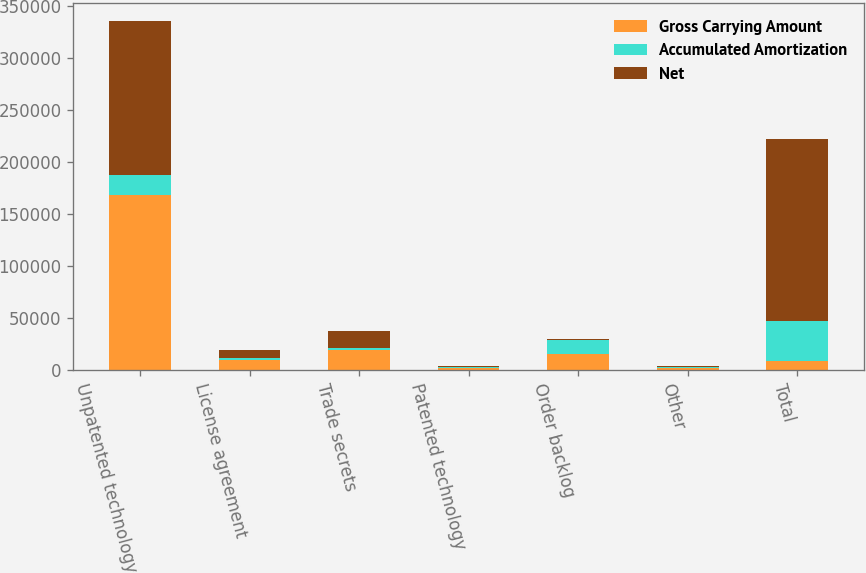Convert chart. <chart><loc_0><loc_0><loc_500><loc_500><stacked_bar_chart><ecel><fcel>Unpatented technology<fcel>License agreement<fcel>Trade secrets<fcel>Patented technology<fcel>Order backlog<fcel>Other<fcel>Total<nl><fcel>Gross Carrying Amount<fcel>168003<fcel>9373<fcel>18462<fcel>1604<fcel>14977<fcel>1600<fcel>8267.5<nl><fcel>Accumulated Amortization<fcel>19178<fcel>2211<fcel>2429<fcel>746<fcel>13471<fcel>513<fcel>38548<nl><fcel>Net<fcel>148825<fcel>7162<fcel>16033<fcel>858<fcel>1506<fcel>1087<fcel>175471<nl></chart> 